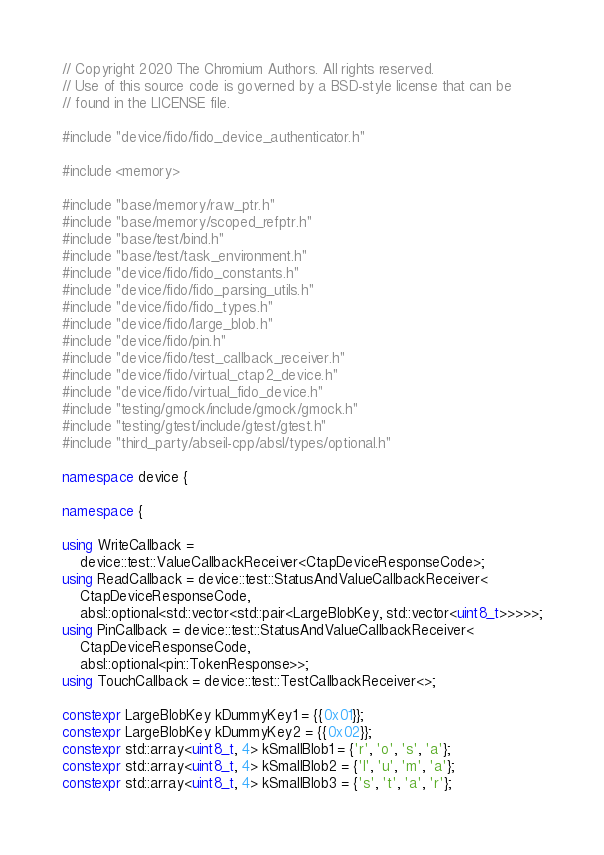<code> <loc_0><loc_0><loc_500><loc_500><_C++_>// Copyright 2020 The Chromium Authors. All rights reserved.
// Use of this source code is governed by a BSD-style license that can be
// found in the LICENSE file.

#include "device/fido/fido_device_authenticator.h"

#include <memory>

#include "base/memory/raw_ptr.h"
#include "base/memory/scoped_refptr.h"
#include "base/test/bind.h"
#include "base/test/task_environment.h"
#include "device/fido/fido_constants.h"
#include "device/fido/fido_parsing_utils.h"
#include "device/fido/fido_types.h"
#include "device/fido/large_blob.h"
#include "device/fido/pin.h"
#include "device/fido/test_callback_receiver.h"
#include "device/fido/virtual_ctap2_device.h"
#include "device/fido/virtual_fido_device.h"
#include "testing/gmock/include/gmock/gmock.h"
#include "testing/gtest/include/gtest/gtest.h"
#include "third_party/abseil-cpp/absl/types/optional.h"

namespace device {

namespace {

using WriteCallback =
    device::test::ValueCallbackReceiver<CtapDeviceResponseCode>;
using ReadCallback = device::test::StatusAndValueCallbackReceiver<
    CtapDeviceResponseCode,
    absl::optional<std::vector<std::pair<LargeBlobKey, std::vector<uint8_t>>>>>;
using PinCallback = device::test::StatusAndValueCallbackReceiver<
    CtapDeviceResponseCode,
    absl::optional<pin::TokenResponse>>;
using TouchCallback = device::test::TestCallbackReceiver<>;

constexpr LargeBlobKey kDummyKey1 = {{0x01}};
constexpr LargeBlobKey kDummyKey2 = {{0x02}};
constexpr std::array<uint8_t, 4> kSmallBlob1 = {'r', 'o', 's', 'a'};
constexpr std::array<uint8_t, 4> kSmallBlob2 = {'l', 'u', 'm', 'a'};
constexpr std::array<uint8_t, 4> kSmallBlob3 = {'s', 't', 'a', 'r'};</code> 